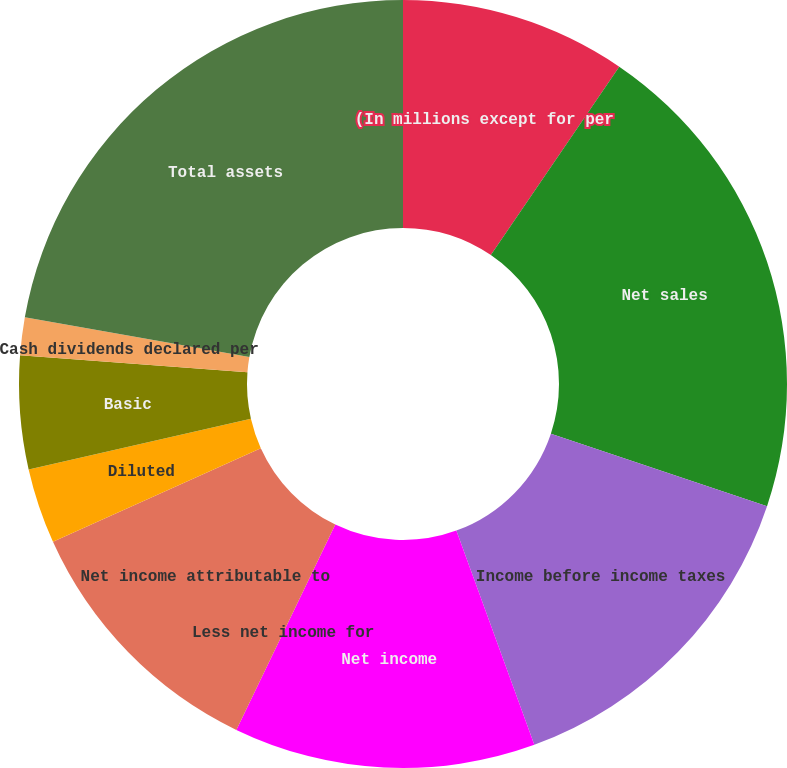Convert chart to OTSL. <chart><loc_0><loc_0><loc_500><loc_500><pie_chart><fcel>(In millions except for per<fcel>Net sales<fcel>Income before income taxes<fcel>Net income<fcel>Less net income for<fcel>Net income attributable to<fcel>Diluted<fcel>Basic<fcel>Cash dividends declared per<fcel>Total assets<nl><fcel>9.52%<fcel>20.63%<fcel>14.29%<fcel>12.7%<fcel>0.0%<fcel>11.11%<fcel>3.17%<fcel>4.76%<fcel>1.59%<fcel>22.22%<nl></chart> 